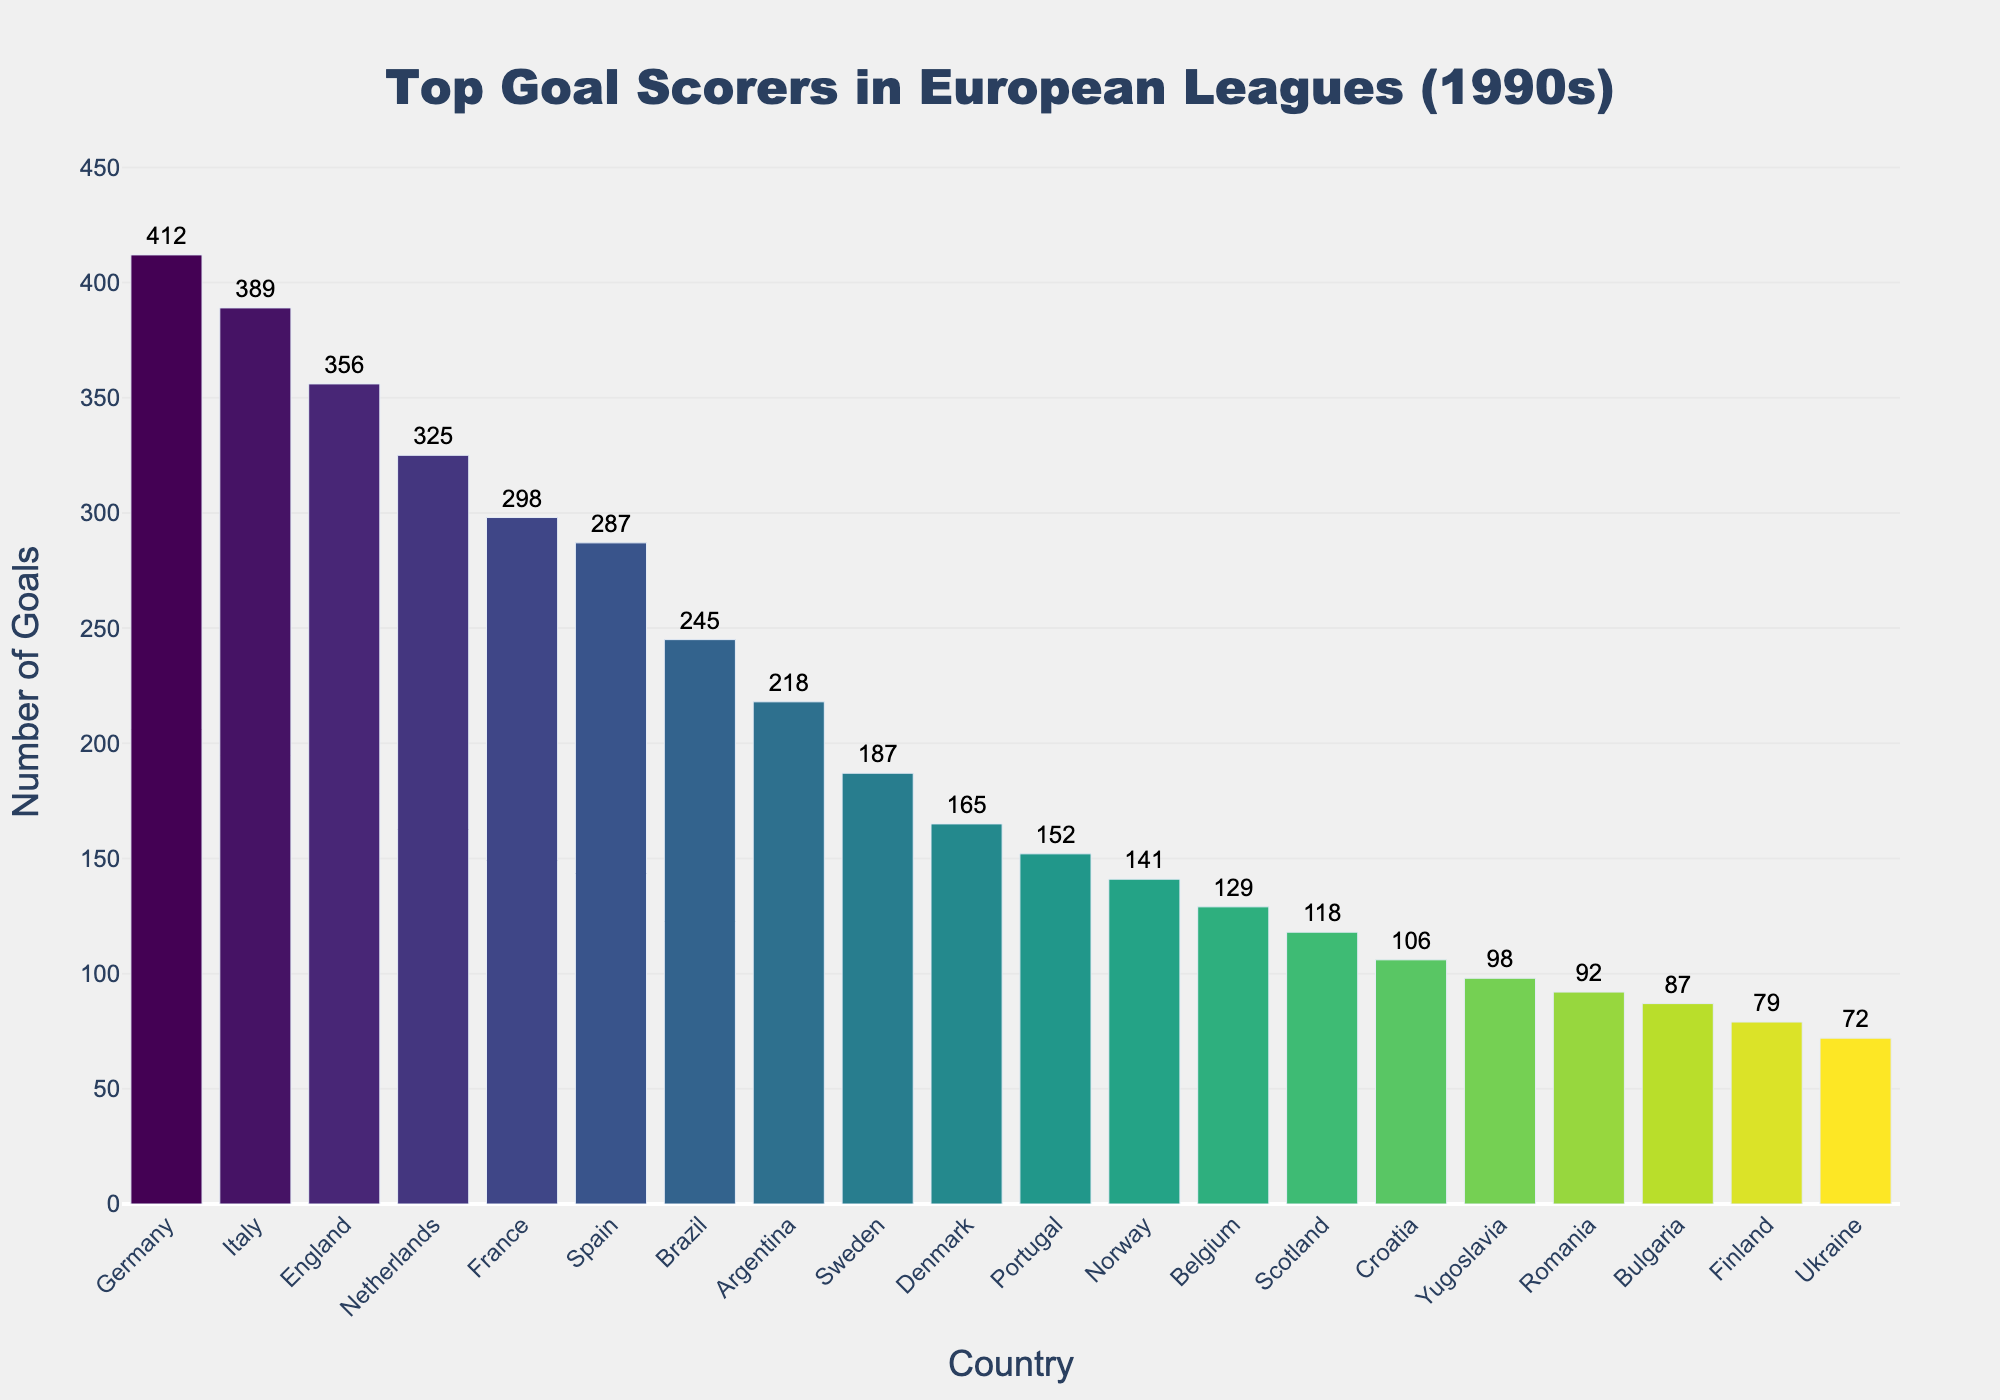Which country has the highest number of goals? Germany has the highest bar on the chart, labeled with 412 goals.
Answer: Germany Which two countries have a similar number of goals, and what are their totals? Italy and England have bars that are of similar height. Italy has 389 goals, and England has 356 goals.
Answer: Italy (389) and England (356) What is the total number of goals scored by Scandinavian countries (Sweden, Denmark, Norway, Finland)? Add the goals for Sweden (187), Denmark (165), Norway (141), and Finland (79). 187 + 165 + 141 + 79 = 572.
Answer: 572 How many more goals did Germany score compared to Brazil? Germany has 412 goals, and Brazil has 245 goals. The difference is 412 - 245 = 167.
Answer: 167 Which country scored the least number of goals, and how many did they score? Ukraine has the shortest bar on the chart with 72 goals.
Answer: Ukraine (72) By how many goals did France outscore Spain? France scored 298 goals and Spain scored 287 goals. The difference is 298 - 287 = 11.
Answer: 11 Which country, among Belgium, Scotland, and Croatia, scored the most goals? Among the three, Belgium scored 129 goals, Scotland scored 118, and Croatia scored 106. Belgium has the highest number of goals.
Answer: Belgium What is the average number of goals scored by the top 5 countries? The top 5 countries are Germany (412), Italy (389), England (356), Netherlands (325), and France (298). The average is (412 + 389 + 356 + 325 + 298) / 5 = 356.
Answer: 356 How many countries scored more than 200 goals? The countries with more than 200 goals are Germany, Italy, England, Netherlands, France, Spain, Brazil, and Argentina. There are 8 countries in this list.
Answer: 8 Which country has a goal total closest to 300? France has 298 goals, which is the closest to 300.
Answer: France 